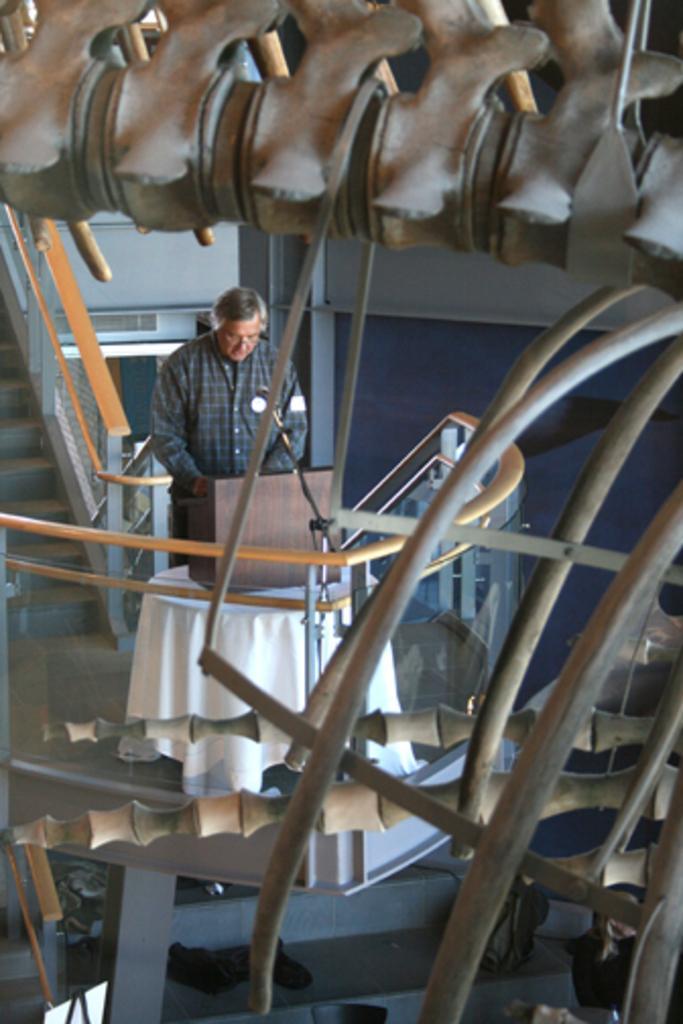Please provide a concise description of this image. In the center of the image there is a person standing. There is a table in front of him with a white color cloth on it. There are staircase. There is staircase railing. In the foreground of the image there is some object. 